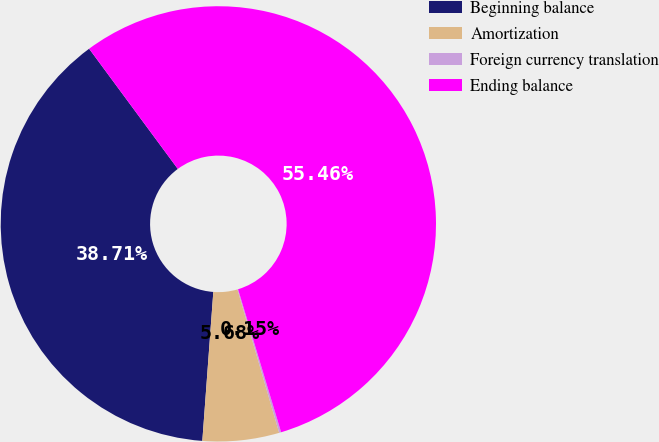Convert chart to OTSL. <chart><loc_0><loc_0><loc_500><loc_500><pie_chart><fcel>Beginning balance<fcel>Amortization<fcel>Foreign currency translation<fcel>Ending balance<nl><fcel>38.71%<fcel>5.68%<fcel>0.15%<fcel>55.46%<nl></chart> 